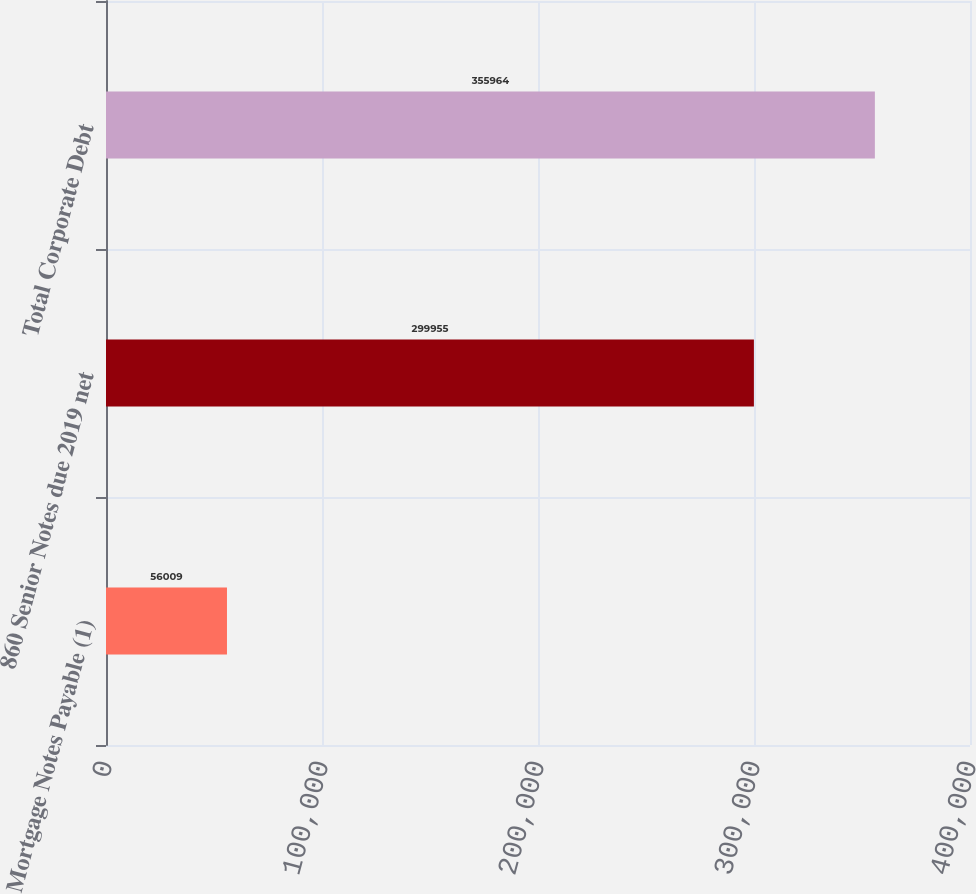Convert chart to OTSL. <chart><loc_0><loc_0><loc_500><loc_500><bar_chart><fcel>Mortgage Notes Payable (1)<fcel>860 Senior Notes due 2019 net<fcel>Total Corporate Debt<nl><fcel>56009<fcel>299955<fcel>355964<nl></chart> 